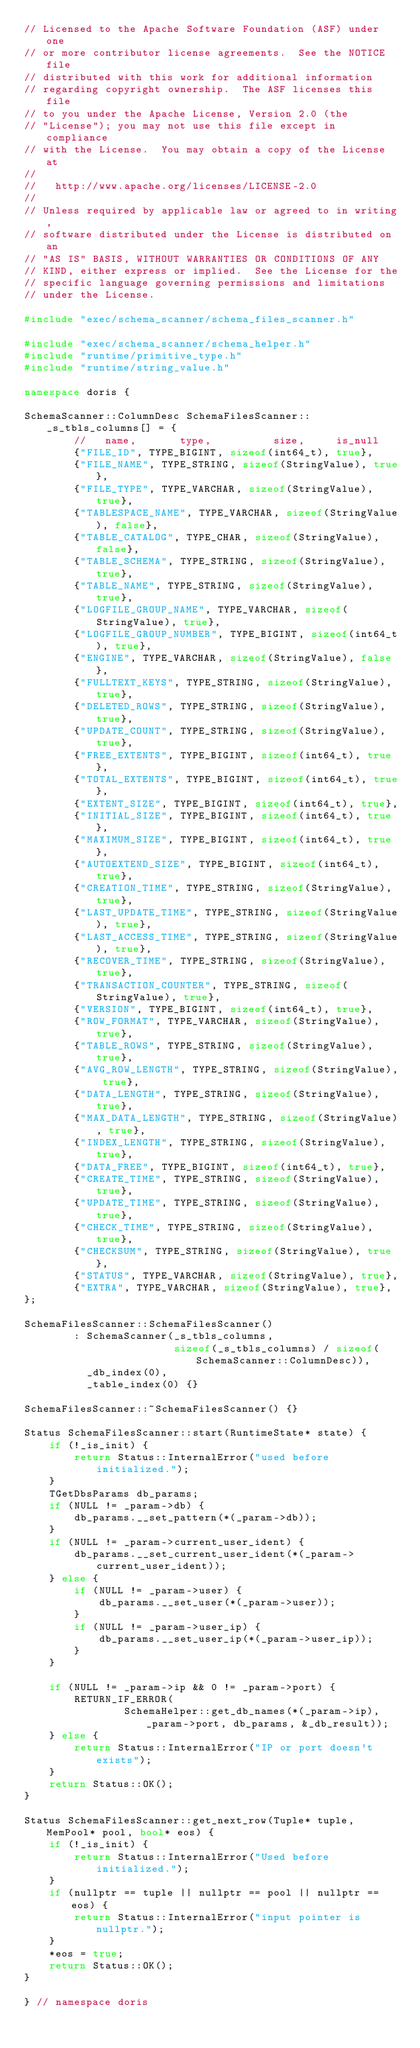Convert code to text. <code><loc_0><loc_0><loc_500><loc_500><_C++_>// Licensed to the Apache Software Foundation (ASF) under one
// or more contributor license agreements.  See the NOTICE file
// distributed with this work for additional information
// regarding copyright ownership.  The ASF licenses this file
// to you under the Apache License, Version 2.0 (the
// "License"); you may not use this file except in compliance
// with the License.  You may obtain a copy of the License at
//
//   http://www.apache.org/licenses/LICENSE-2.0
//
// Unless required by applicable law or agreed to in writing,
// software distributed under the License is distributed on an
// "AS IS" BASIS, WITHOUT WARRANTIES OR CONDITIONS OF ANY
// KIND, either express or implied.  See the License for the
// specific language governing permissions and limitations
// under the License.

#include "exec/schema_scanner/schema_files_scanner.h"

#include "exec/schema_scanner/schema_helper.h"
#include "runtime/primitive_type.h"
#include "runtime/string_value.h"

namespace doris {

SchemaScanner::ColumnDesc SchemaFilesScanner::_s_tbls_columns[] = {
        //   name,       type,          size,     is_null
        {"FILE_ID", TYPE_BIGINT, sizeof(int64_t), true},
        {"FILE_NAME", TYPE_STRING, sizeof(StringValue), true},
        {"FILE_TYPE", TYPE_VARCHAR, sizeof(StringValue), true},
        {"TABLESPACE_NAME", TYPE_VARCHAR, sizeof(StringValue), false},
        {"TABLE_CATALOG", TYPE_CHAR, sizeof(StringValue), false},
        {"TABLE_SCHEMA", TYPE_STRING, sizeof(StringValue), true},
        {"TABLE_NAME", TYPE_STRING, sizeof(StringValue), true},
        {"LOGFILE_GROUP_NAME", TYPE_VARCHAR, sizeof(StringValue), true},
        {"LOGFILE_GROUP_NUMBER", TYPE_BIGINT, sizeof(int64_t), true},
        {"ENGINE", TYPE_VARCHAR, sizeof(StringValue), false},
        {"FULLTEXT_KEYS", TYPE_STRING, sizeof(StringValue), true},
        {"DELETED_ROWS", TYPE_STRING, sizeof(StringValue), true},
        {"UPDATE_COUNT", TYPE_STRING, sizeof(StringValue), true},
        {"FREE_EXTENTS", TYPE_BIGINT, sizeof(int64_t), true},
        {"TOTAL_EXTENTS", TYPE_BIGINT, sizeof(int64_t), true},
        {"EXTENT_SIZE", TYPE_BIGINT, sizeof(int64_t), true},
        {"INITIAL_SIZE", TYPE_BIGINT, sizeof(int64_t), true},
        {"MAXIMUM_SIZE", TYPE_BIGINT, sizeof(int64_t), true},
        {"AUTOEXTEND_SIZE", TYPE_BIGINT, sizeof(int64_t), true},
        {"CREATION_TIME", TYPE_STRING, sizeof(StringValue), true},
        {"LAST_UPDATE_TIME", TYPE_STRING, sizeof(StringValue), true},
        {"LAST_ACCESS_TIME", TYPE_STRING, sizeof(StringValue), true},
        {"RECOVER_TIME", TYPE_STRING, sizeof(StringValue), true},
        {"TRANSACTION_COUNTER", TYPE_STRING, sizeof(StringValue), true},
        {"VERSION", TYPE_BIGINT, sizeof(int64_t), true},
        {"ROW_FORMAT", TYPE_VARCHAR, sizeof(StringValue), true},
        {"TABLE_ROWS", TYPE_STRING, sizeof(StringValue), true},
        {"AVG_ROW_LENGTH", TYPE_STRING, sizeof(StringValue), true},
        {"DATA_LENGTH", TYPE_STRING, sizeof(StringValue), true},
        {"MAX_DATA_LENGTH", TYPE_STRING, sizeof(StringValue), true},
        {"INDEX_LENGTH", TYPE_STRING, sizeof(StringValue), true},
        {"DATA_FREE", TYPE_BIGINT, sizeof(int64_t), true},
        {"CREATE_TIME", TYPE_STRING, sizeof(StringValue), true},
        {"UPDATE_TIME", TYPE_STRING, sizeof(StringValue), true},
        {"CHECK_TIME", TYPE_STRING, sizeof(StringValue), true},
        {"CHECKSUM", TYPE_STRING, sizeof(StringValue), true},
        {"STATUS", TYPE_VARCHAR, sizeof(StringValue), true},
        {"EXTRA", TYPE_VARCHAR, sizeof(StringValue), true},
};

SchemaFilesScanner::SchemaFilesScanner()
        : SchemaScanner(_s_tbls_columns,
                        sizeof(_s_tbls_columns) / sizeof(SchemaScanner::ColumnDesc)),
          _db_index(0),
          _table_index(0) {}

SchemaFilesScanner::~SchemaFilesScanner() {}

Status SchemaFilesScanner::start(RuntimeState* state) {
    if (!_is_init) {
        return Status::InternalError("used before initialized.");
    }
    TGetDbsParams db_params;
    if (NULL != _param->db) {
        db_params.__set_pattern(*(_param->db));
    }
    if (NULL != _param->current_user_ident) {
        db_params.__set_current_user_ident(*(_param->current_user_ident));
    } else {
        if (NULL != _param->user) {
            db_params.__set_user(*(_param->user));
        }
        if (NULL != _param->user_ip) {
            db_params.__set_user_ip(*(_param->user_ip));
        }
    }

    if (NULL != _param->ip && 0 != _param->port) {
        RETURN_IF_ERROR(
                SchemaHelper::get_db_names(*(_param->ip), _param->port, db_params, &_db_result));
    } else {
        return Status::InternalError("IP or port doesn't exists");
    }
    return Status::OK();
}

Status SchemaFilesScanner::get_next_row(Tuple* tuple, MemPool* pool, bool* eos) {
    if (!_is_init) {
        return Status::InternalError("Used before initialized.");
    }
    if (nullptr == tuple || nullptr == pool || nullptr == eos) {
        return Status::InternalError("input pointer is nullptr.");
    }
    *eos = true;
    return Status::OK();
}

} // namespace doris
</code> 